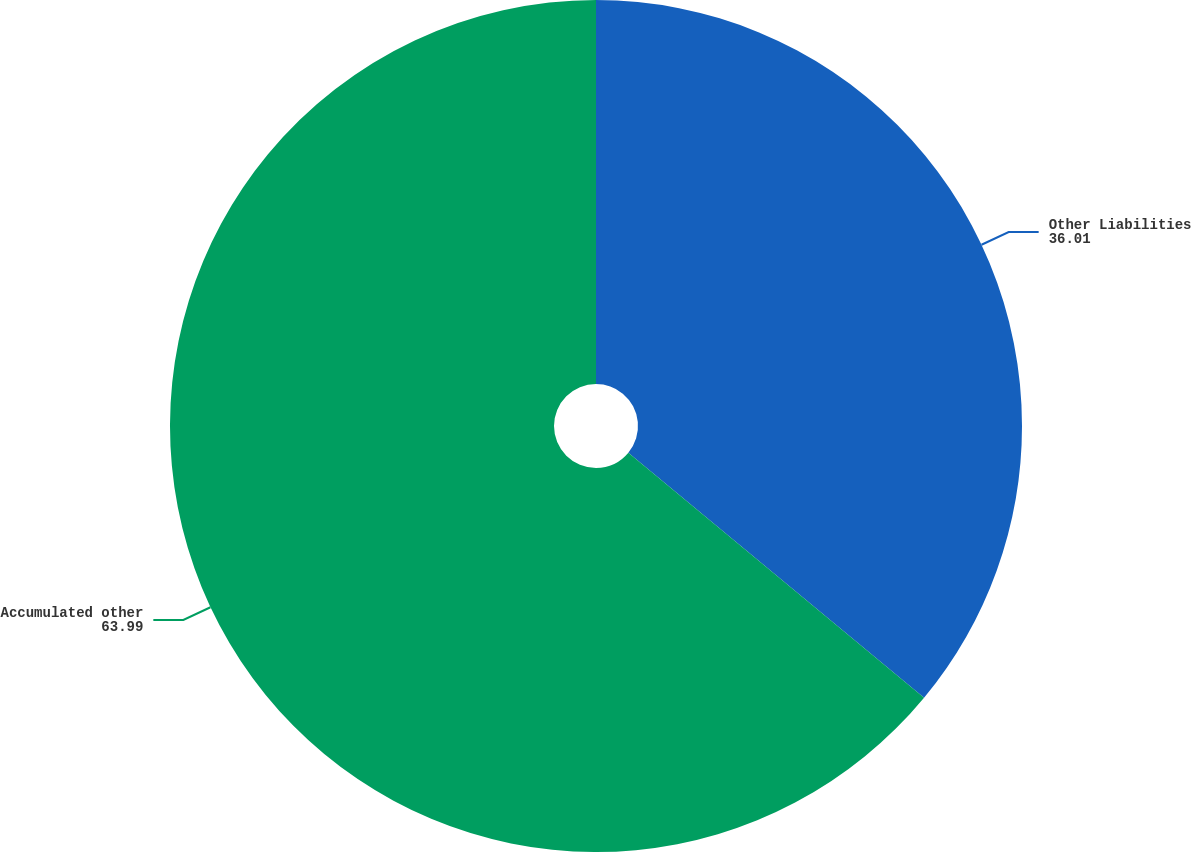<chart> <loc_0><loc_0><loc_500><loc_500><pie_chart><fcel>Other Liabilities<fcel>Accumulated other<nl><fcel>36.01%<fcel>63.99%<nl></chart> 